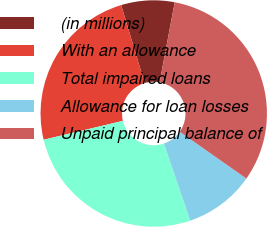Convert chart. <chart><loc_0><loc_0><loc_500><loc_500><pie_chart><fcel>(in millions)<fcel>With an allowance<fcel>Total impaired loans<fcel>Allowance for loan losses<fcel>Unpaid principal balance of<nl><fcel>7.62%<fcel>24.08%<fcel>26.49%<fcel>10.04%<fcel>31.77%<nl></chart> 